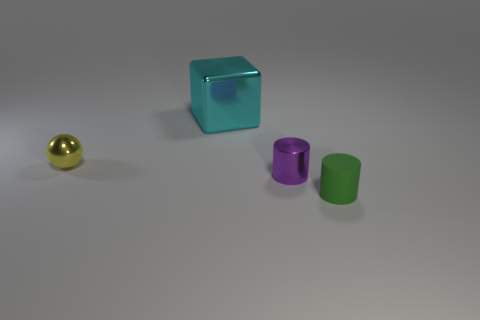Subtract 1 cylinders. How many cylinders are left? 1 Add 3 shiny things. How many shiny things are left? 6 Add 4 large blue cylinders. How many large blue cylinders exist? 4 Add 3 small blue matte blocks. How many objects exist? 7 Subtract all green cylinders. How many cylinders are left? 1 Subtract 1 cyan blocks. How many objects are left? 3 Subtract all balls. How many objects are left? 3 Subtract all blue spheres. Subtract all yellow blocks. How many spheres are left? 1 Subtract all gray balls. How many green cylinders are left? 1 Subtract all green cylinders. Subtract all big shiny blocks. How many objects are left? 2 